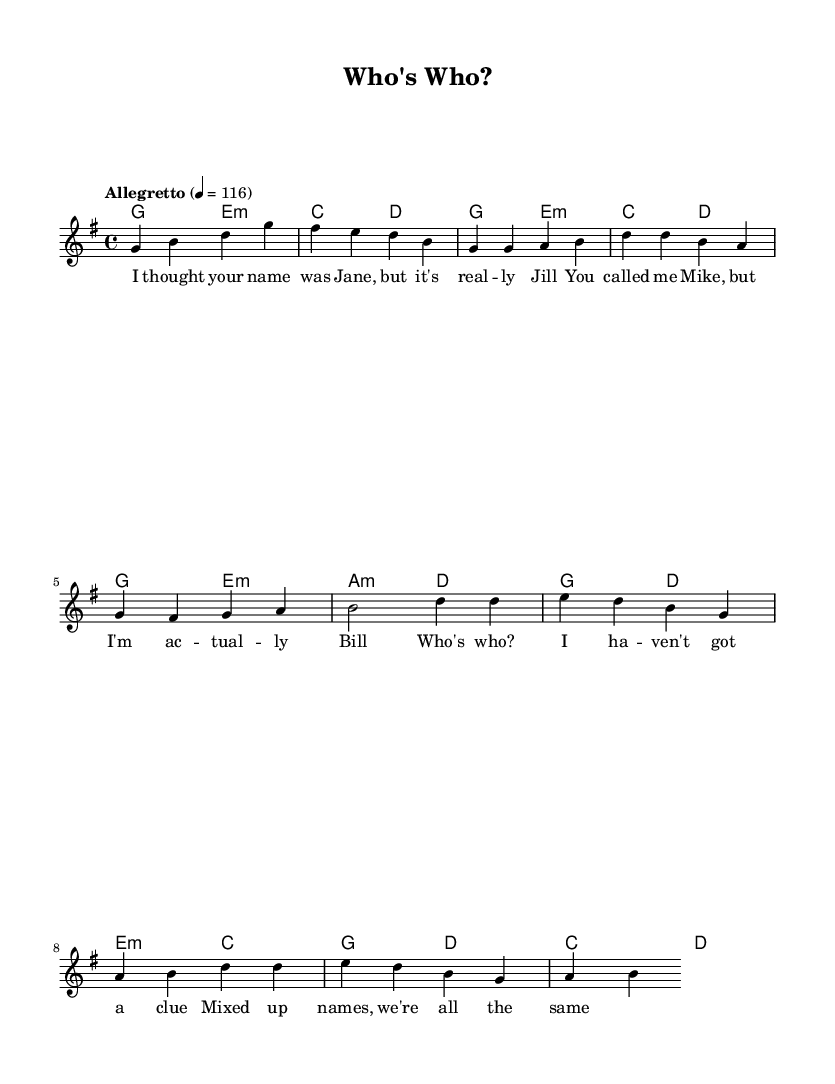What is the key signature of this music? The key signature is G major, which has one sharp (F#). This is evident in the global settings of the sheet music.
Answer: G major What is the time signature of this piece? The time signature is 4/4, indicated in the global settings of the sheet music where it states the measure is divided into four beats per measure.
Answer: 4/4 What is the tempo marking of this song? The tempo marking is "Allegretto" with a speed of 116 beats per minute, which is found in the tempo instruction within the global settings.
Answer: Allegretto How many measures are in the verse? The verse consists of four measures. This can be determined by counting the measures in the verse section of the melody.
Answer: Four What does the chorus primarily express? The chorus expresses confusion about identity, specifically asking "Who's who?" and mentioning mixed-up names, as shown in the lyrics of the chorus section.
Answer: Confusion Which chord follows the G major chord in the intro? The chord that follows the G major chord in the intro is E minor, which is noted in the harmonies section of the sheet music.
Answer: E minor What is the lyrical theme of this song? The lyrical theme revolves around mistaken identities and name mix-ups, highlighted in the lyrics throughout the verse and chorus.
Answer: Mistaken identities 